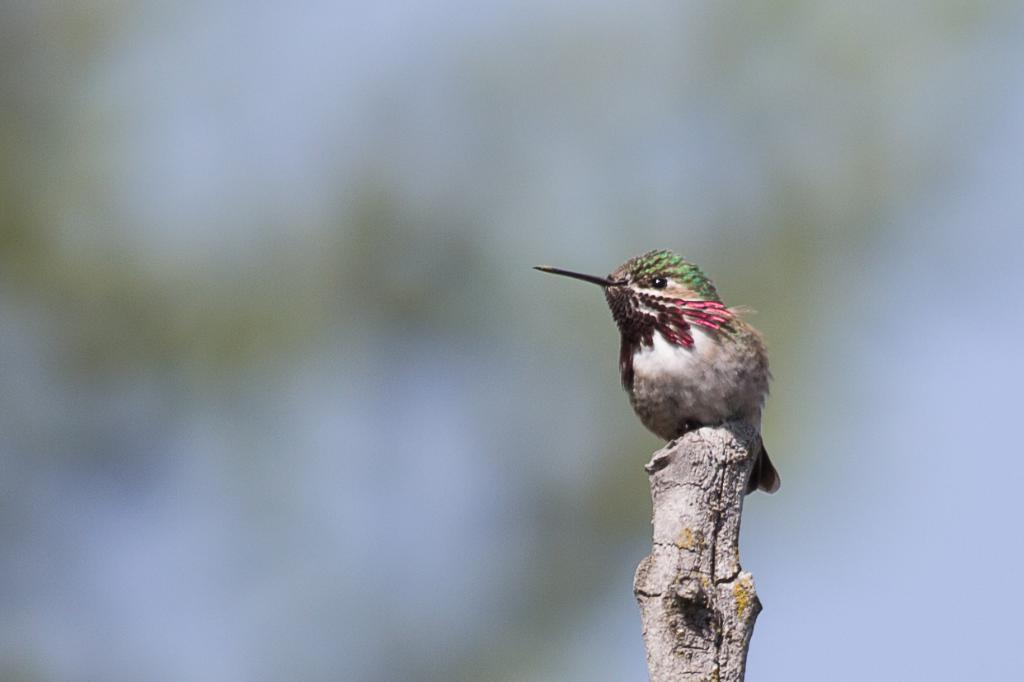What type of animal is in the image? There is a bird in the image. What is the bird standing on? The bird is on wood. Can you describe the background of the image? The background of the image is blurred. Is there a lake visible in the background of the image? No, there is no lake visible in the background of the image. 